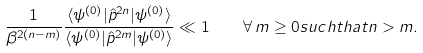Convert formula to latex. <formula><loc_0><loc_0><loc_500><loc_500>\frac { 1 } { \beta ^ { 2 ( n - m ) } } \frac { \langle \psi ^ { ( 0 ) } | \hat { p } ^ { 2 n } | \psi ^ { ( 0 ) } \rangle } { \langle \psi ^ { ( 0 ) } | \hat { p } ^ { 2 m } | \psi ^ { ( 0 ) } \rangle } \ll 1 \quad \forall \, m \geq 0 s u c h t h a t n > m .</formula> 